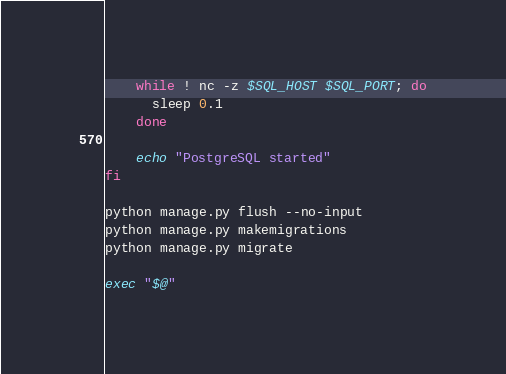Convert code to text. <code><loc_0><loc_0><loc_500><loc_500><_Bash_>    while ! nc -z $SQL_HOST $SQL_PORT; do
      sleep 0.1
    done

    echo "PostgreSQL started"
fi

python manage.py flush --no-input
python manage.py makemigrations
python manage.py migrate

exec "$@"</code> 